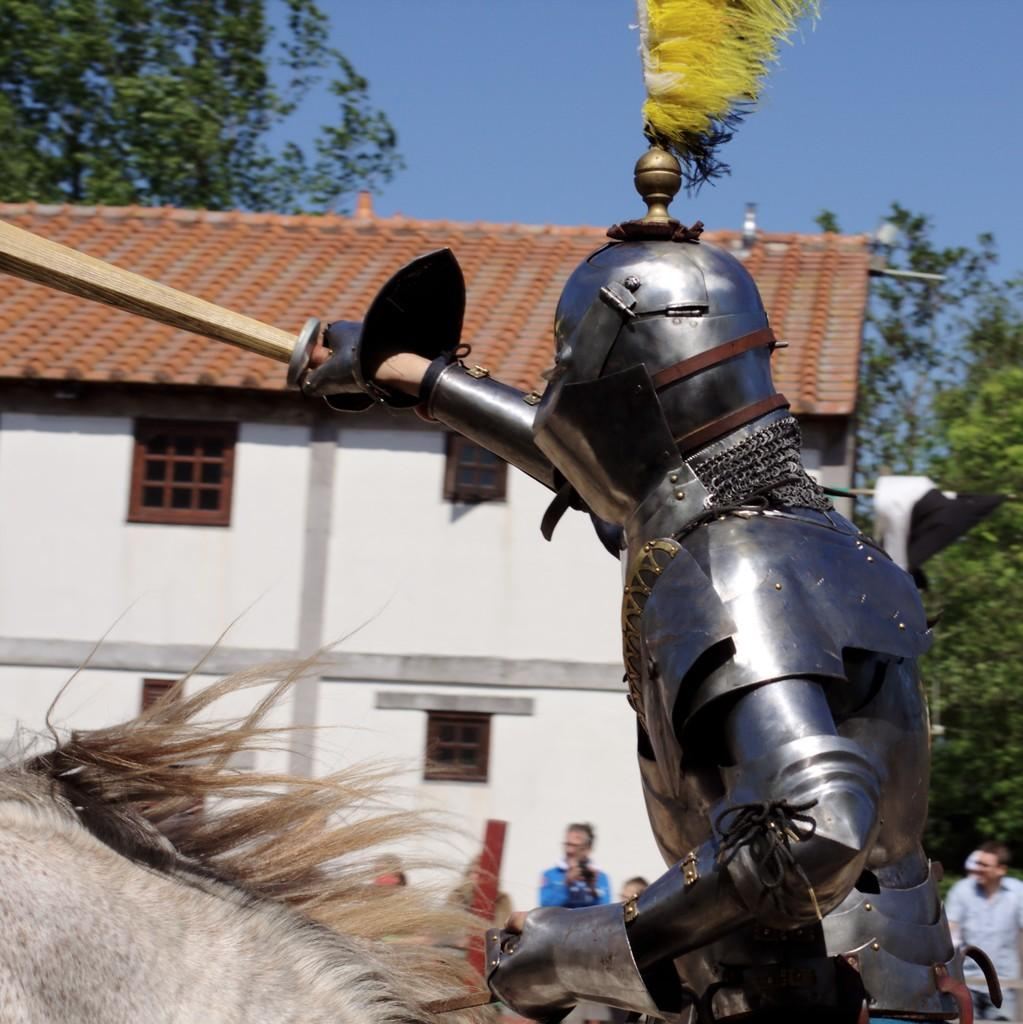What type of structure is visible in the image? There is a building in the image. What feature can be seen on the building? The building has windows. What else is present in the image besides the building? There are trees, people, and a person wearing a different costume in the image. What is the person wearing a different costume holding? The person is holding something. What is the color of the sky in the image? The sky is blue in color. How many ears can be seen on the fowl in the image? There is no fowl present in the image, so it is not possible to determine the number of ears. 